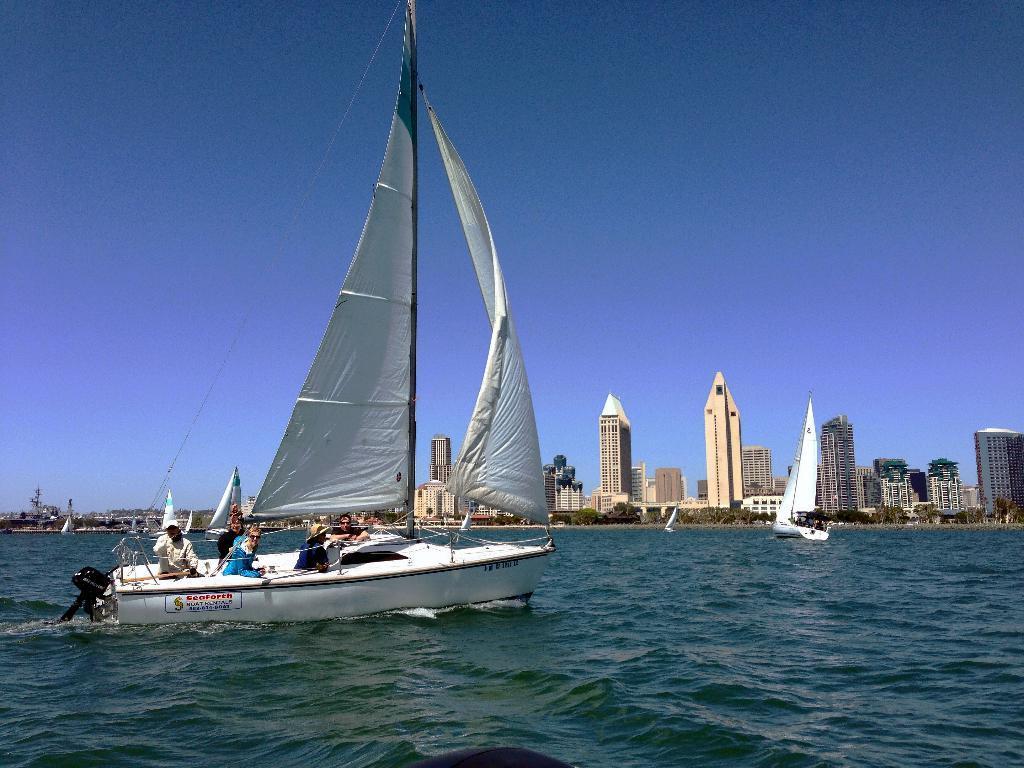Please provide a concise description of this image. In this image on the water body there are many boats. Here on the boat there are few people. In the background there are buildings, trees. The sky is clear. 